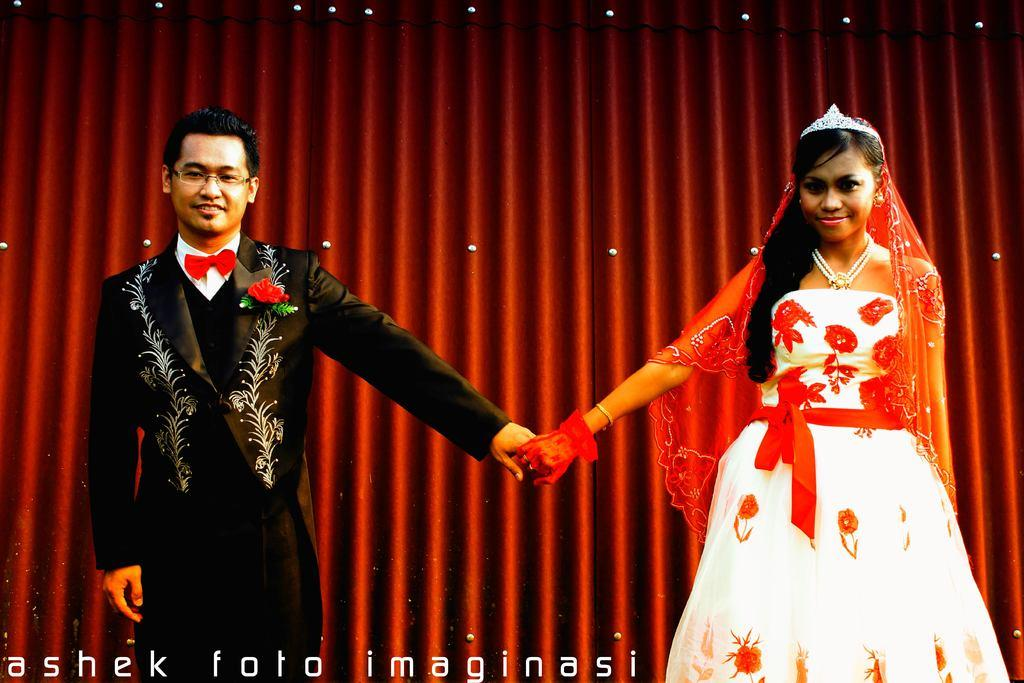Who are the people in the image? There is a man and a lady in the image. What are the man and lady doing in the image? The man and lady are standing and holding hands. What can be seen in the background of the image? There is a red curtain in the background of the image. What is present on the bottom left of the image? There is text on the bottom left of the image. How many sisters are present in the image? There is no mention of a sister in the image; it features a man and a lady holding hands. What type of cent can be seen in the image? There is no cent present in the image. 